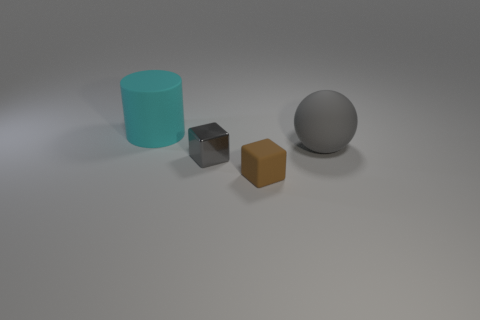Add 3 small cylinders. How many objects exist? 7 Subtract all cylinders. How many objects are left? 3 Add 2 big cyan cylinders. How many big cyan cylinders exist? 3 Subtract 0 purple cylinders. How many objects are left? 4 Subtract all rubber blocks. Subtract all small brown matte objects. How many objects are left? 2 Add 3 spheres. How many spheres are left? 4 